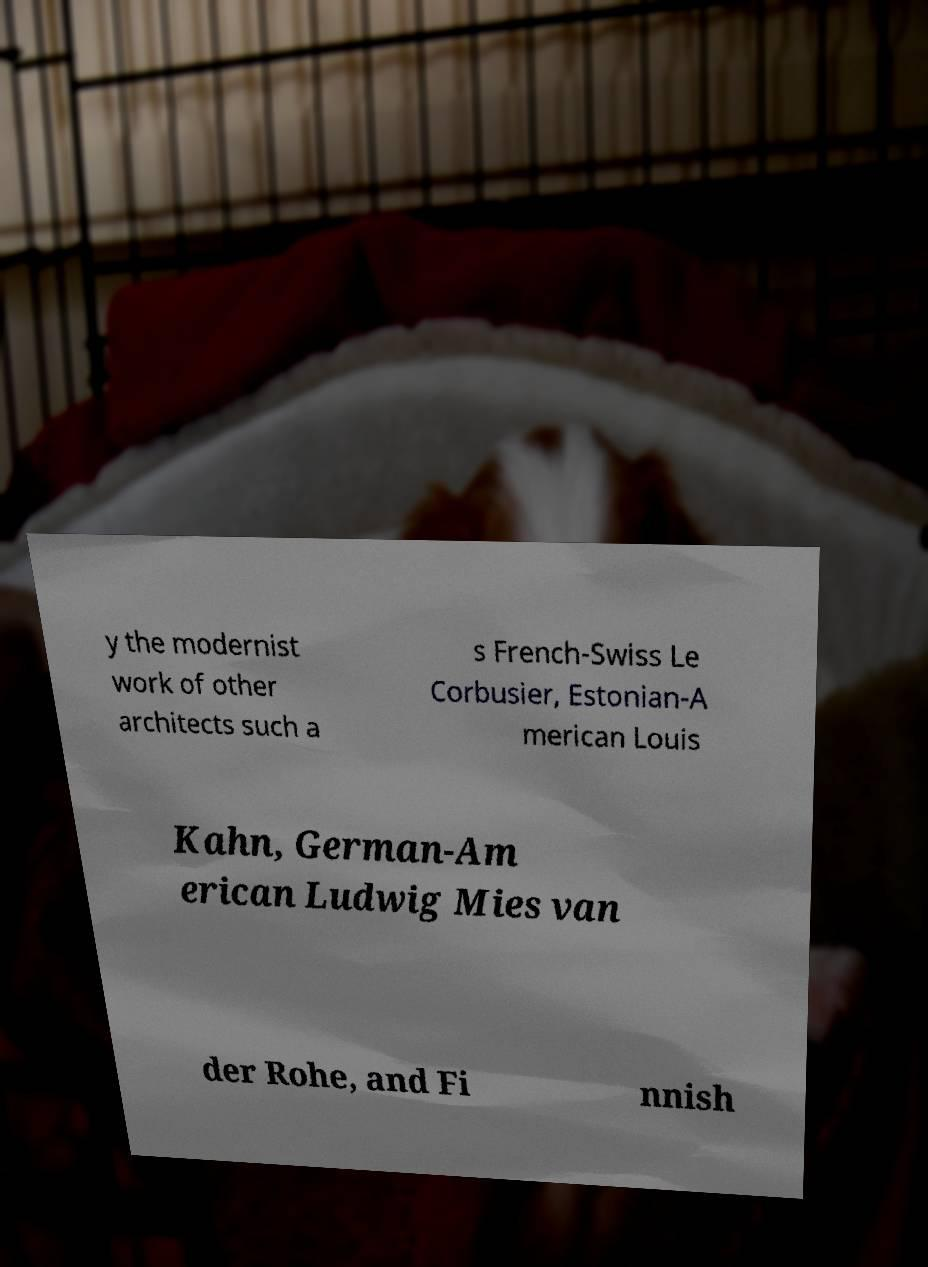There's text embedded in this image that I need extracted. Can you transcribe it verbatim? y the modernist work of other architects such a s French-Swiss Le Corbusier, Estonian-A merican Louis Kahn, German-Am erican Ludwig Mies van der Rohe, and Fi nnish 